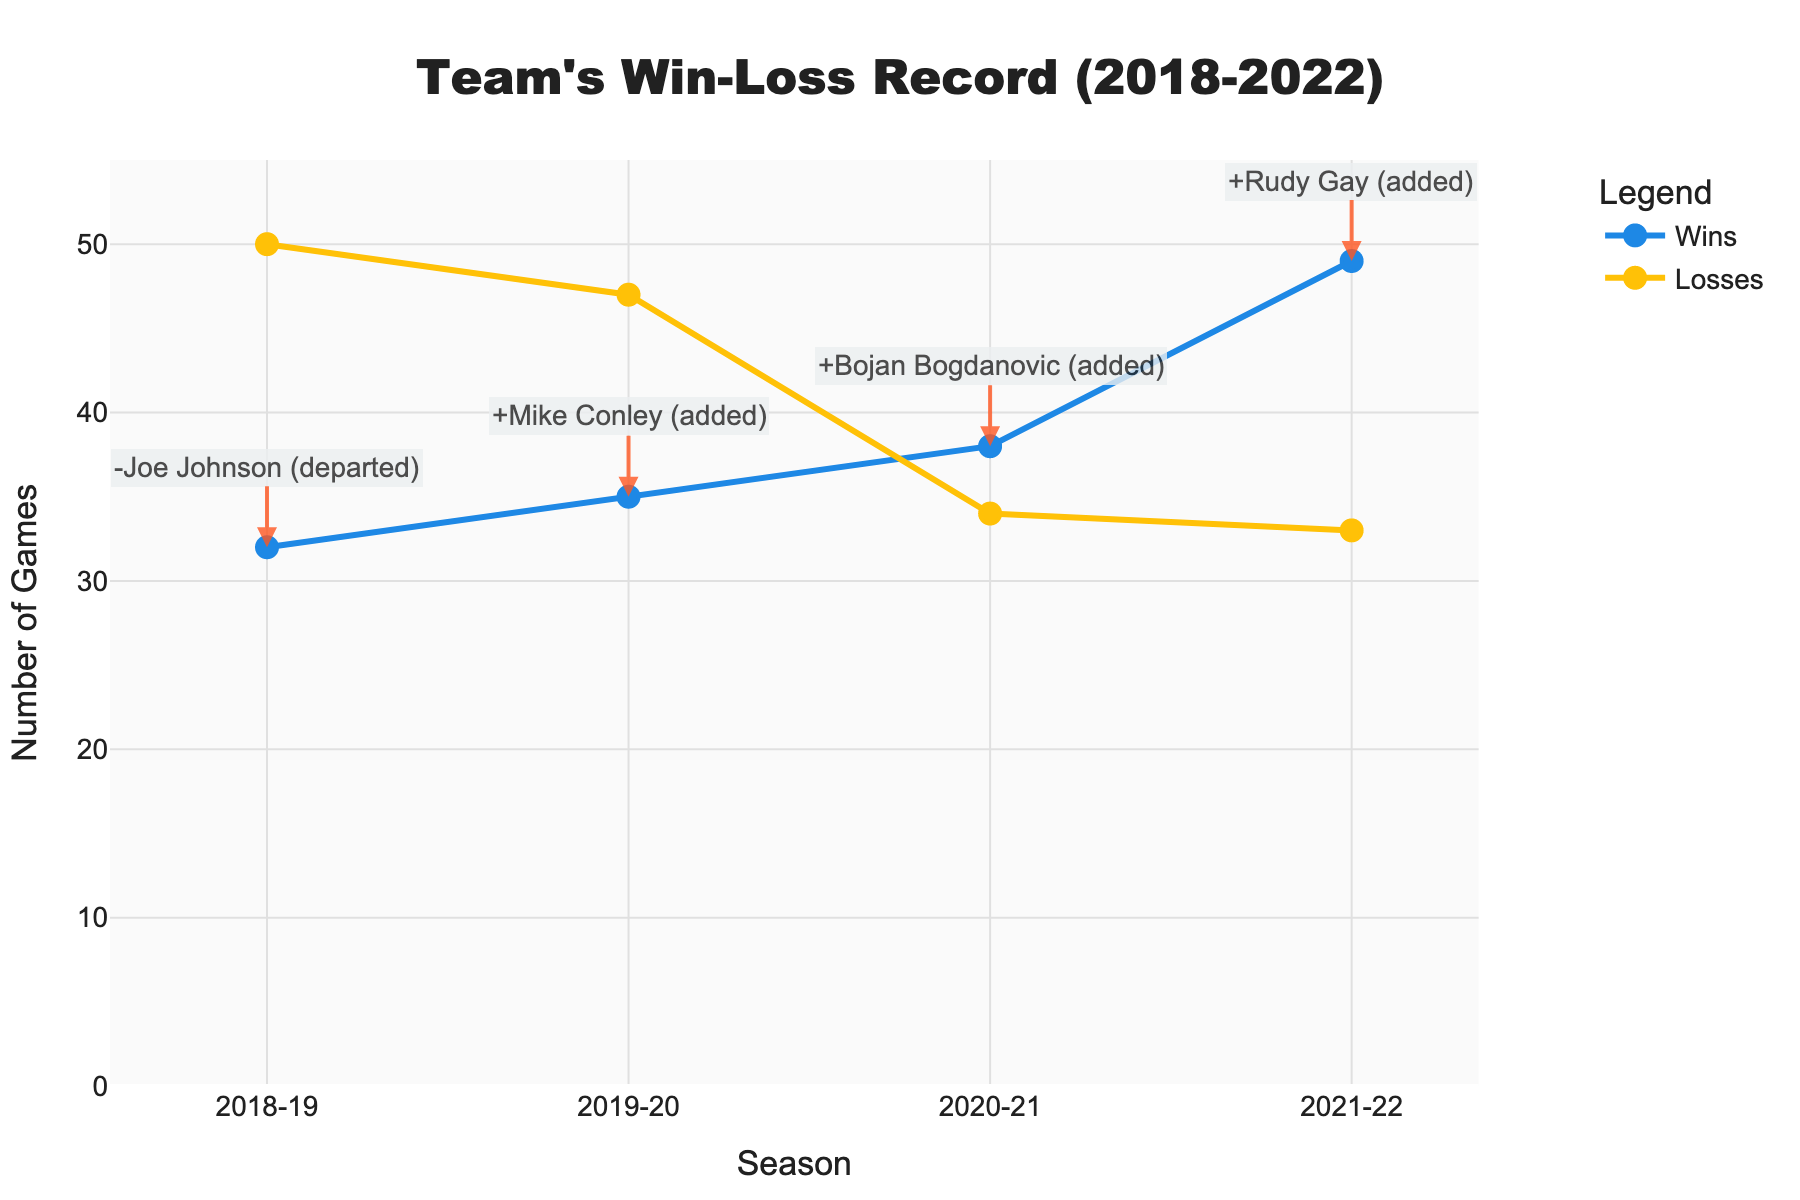Who had the higher number of wins, the 2018-19 season or the 2019-20 season? In the chart, the blue line with markers represents wins. For the 2018-19 season, the number of wins is 32, and for the 2019-20 season, it is 35. Comparing these two values, 35 is greater than 32.
Answer: 2019-20 season What is the difference in losses between the 2019-20 and 2021-22 seasons? The number of losses is depicted by the orange line with markers. The 2019-20 season shows 47 losses, and the 2021-22 season shows 33 losses. The difference is 47 - 33 = 14.
Answer: 14 How many total wins did the team secure over the 5 seasons presented? To find the total wins, add the wins from each season: 32 + 35 + 38 + 49. The total is 154.
Answer: 154 Which season had the biggest improvement in the number of wins compared to the previous season? To determine the biggest improvement, find the differences in wins between consecutive seasons: 35-32 = 3 (2018-19 to 2019-20), 38-35 = 3 (2019-20 to 2020-21), 49-38 = 11 (2020-21 to 2021-22). The biggest improvement is 11 wins between the 2020-21 and 2021-22 seasons.
Answer: 2020-21 to 2021-22 What key player change happened in the season with the highest number of wins? The annotations on the chart provide key player changes. The season with the highest number of wins (49) is the 2021-22 season. The annotation shows "+ Rudy Gay (added)".
Answer: + Rudy Gay (added) In which season did the team have an equal or fewer number of losses compared to the number of wins in the next season? Compare losses from one season to wins in the next: 50 (2018-19 losses) and 35 (2019-20 wins) - not true, 47 (2019-20 losses) and 38 (2020-21 wins) - not true, 34 (2020-21 losses) and 49 (2021-22 wins) - true. The 2020-21 season fits this criterion.
Answer: 2020-21 How many seasons experienced a positive change in wins compared to the previous season? Calculate the change in wins for each season: 35-32 = 3 (positive), 38-35 = 3 (positive), 49-38 = 11 (positive). All three changes are positive. Therefore, 3 seasons had a positive change in wins.
Answer: 3 Which season had the highest number of losses and what was the key change that season? The season with the highest number of losses (50) is the 2018-19 season. The annotation for this season reads "-Joe Johnson (departed)".
Answer: 2018-19, -Joe Johnson (departed) What is the average number of losses over the 5 seasons? Add the losses over the 5 seasons and then divide by 5: (50 + 47 + 34 + 33) = 164, 164/5 = 41.
Answer: 41 